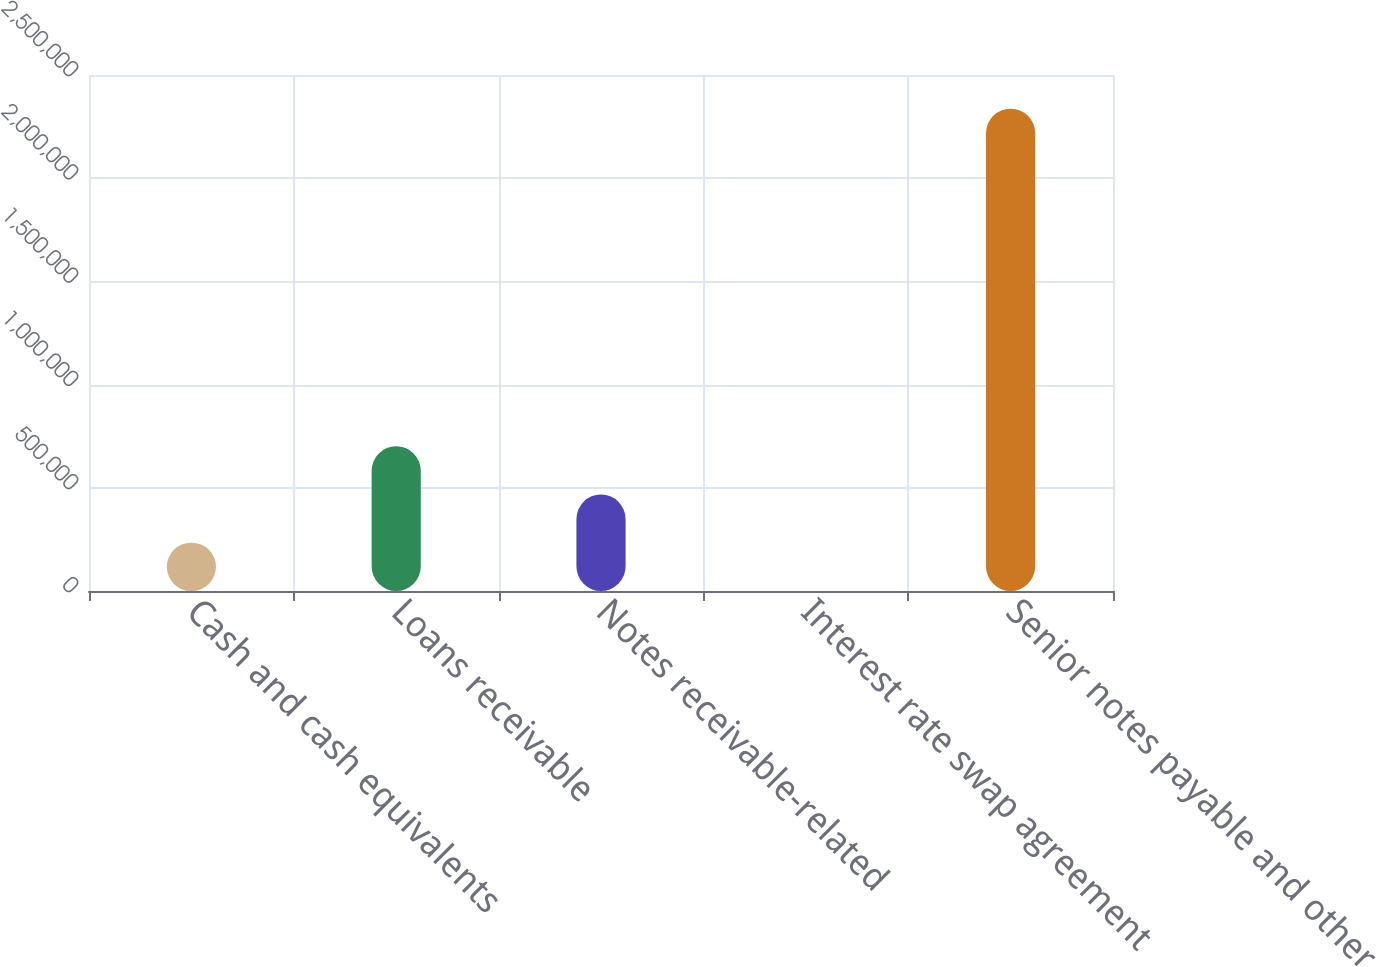Convert chart to OTSL. <chart><loc_0><loc_0><loc_500><loc_500><bar_chart><fcel>Cash and cash equivalents<fcel>Loans receivable<fcel>Notes receivable-related<fcel>Interest rate swap agreement<fcel>Senior notes payable and other<nl><fcel>234085<fcel>701397<fcel>467741<fcel>429<fcel>2.33699e+06<nl></chart> 